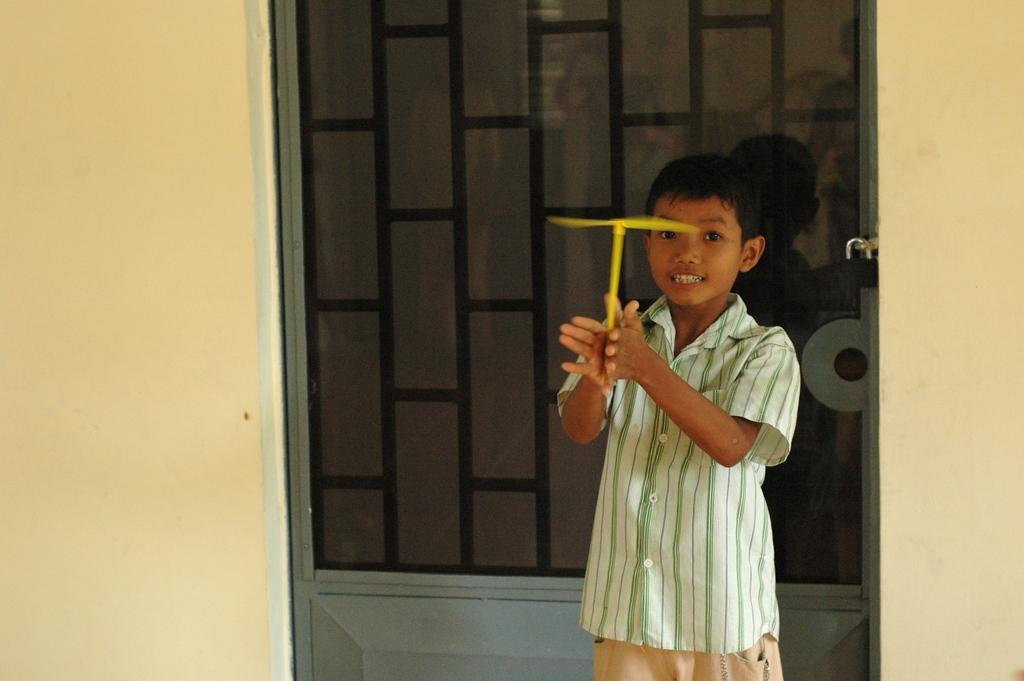What is the main subject in the foreground of the image? There is a boy in the foreground of the image. What is the boy holding in his hand? The boy is holding a toy in his hand. What can be seen in the background of the image? There is a door and a wall in the background of the image. Can you see a stream of water flowing behind the boy in the image? There is no stream of water visible in the image. 